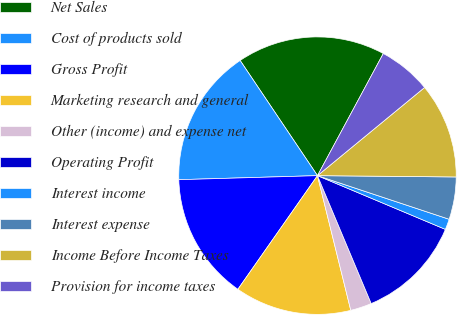Convert chart. <chart><loc_0><loc_0><loc_500><loc_500><pie_chart><fcel>Net Sales<fcel>Cost of products sold<fcel>Gross Profit<fcel>Marketing research and general<fcel>Other (income) and expense net<fcel>Operating Profit<fcel>Interest income<fcel>Interest expense<fcel>Income Before Income Taxes<fcel>Provision for income taxes<nl><fcel>17.28%<fcel>16.05%<fcel>14.81%<fcel>13.58%<fcel>2.47%<fcel>12.34%<fcel>1.24%<fcel>4.94%<fcel>11.11%<fcel>6.17%<nl></chart> 